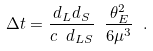Convert formula to latex. <formula><loc_0><loc_0><loc_500><loc_500>\Delta t = \frac { d _ { L } d _ { S } } { c \ d _ { L S } } \ \frac { \theta _ { E } ^ { 2 } } { 6 \mu ^ { 3 } } \ .</formula> 